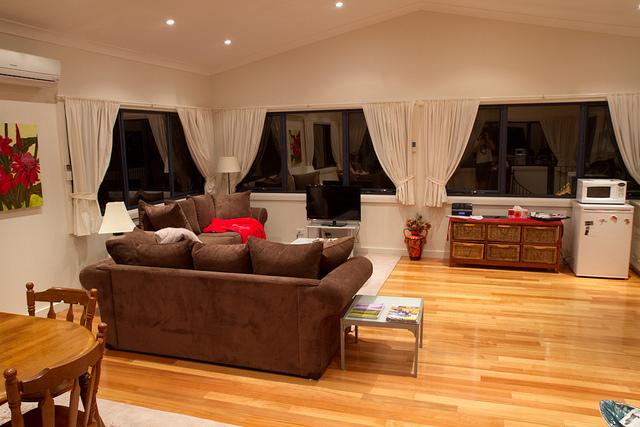Is the house tidy?
Write a very short answer. Yes. Are there paintings on the wall?
Give a very brief answer. Yes. What room is this?
Concise answer only. Living room. 